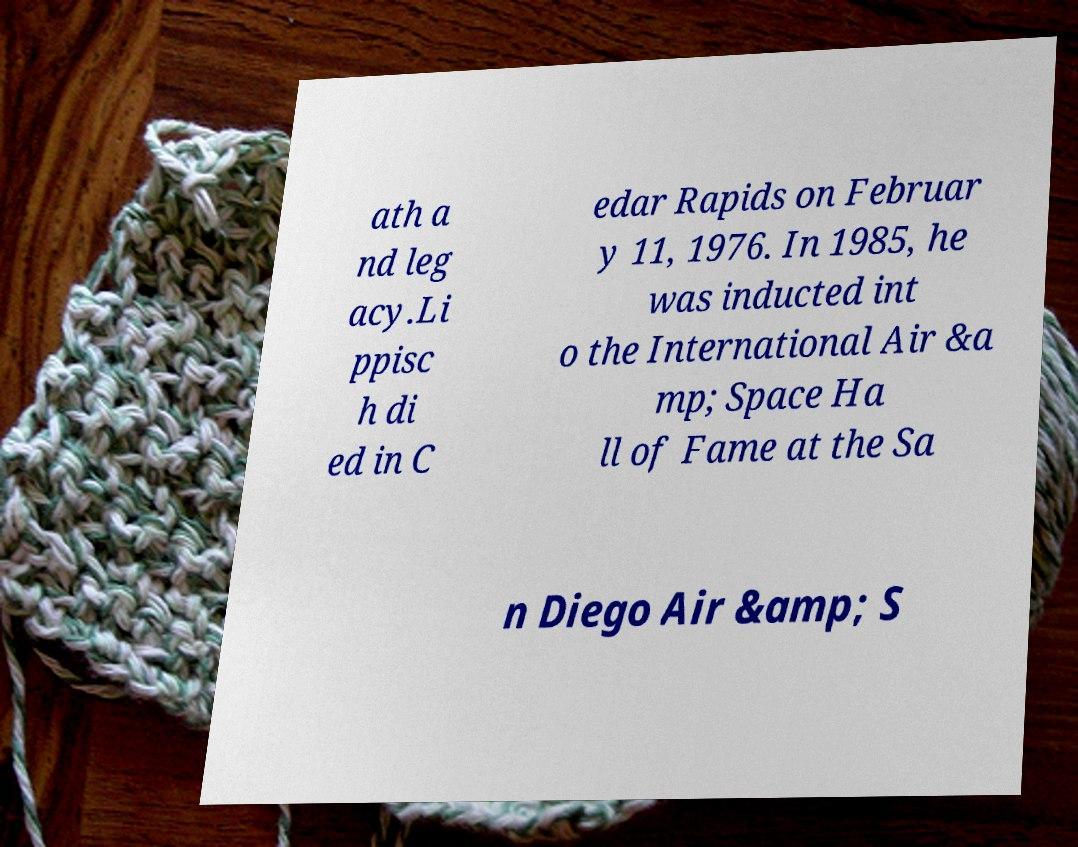I need the written content from this picture converted into text. Can you do that? ath a nd leg acy.Li ppisc h di ed in C edar Rapids on Februar y 11, 1976. In 1985, he was inducted int o the International Air &a mp; Space Ha ll of Fame at the Sa n Diego Air &amp; S 